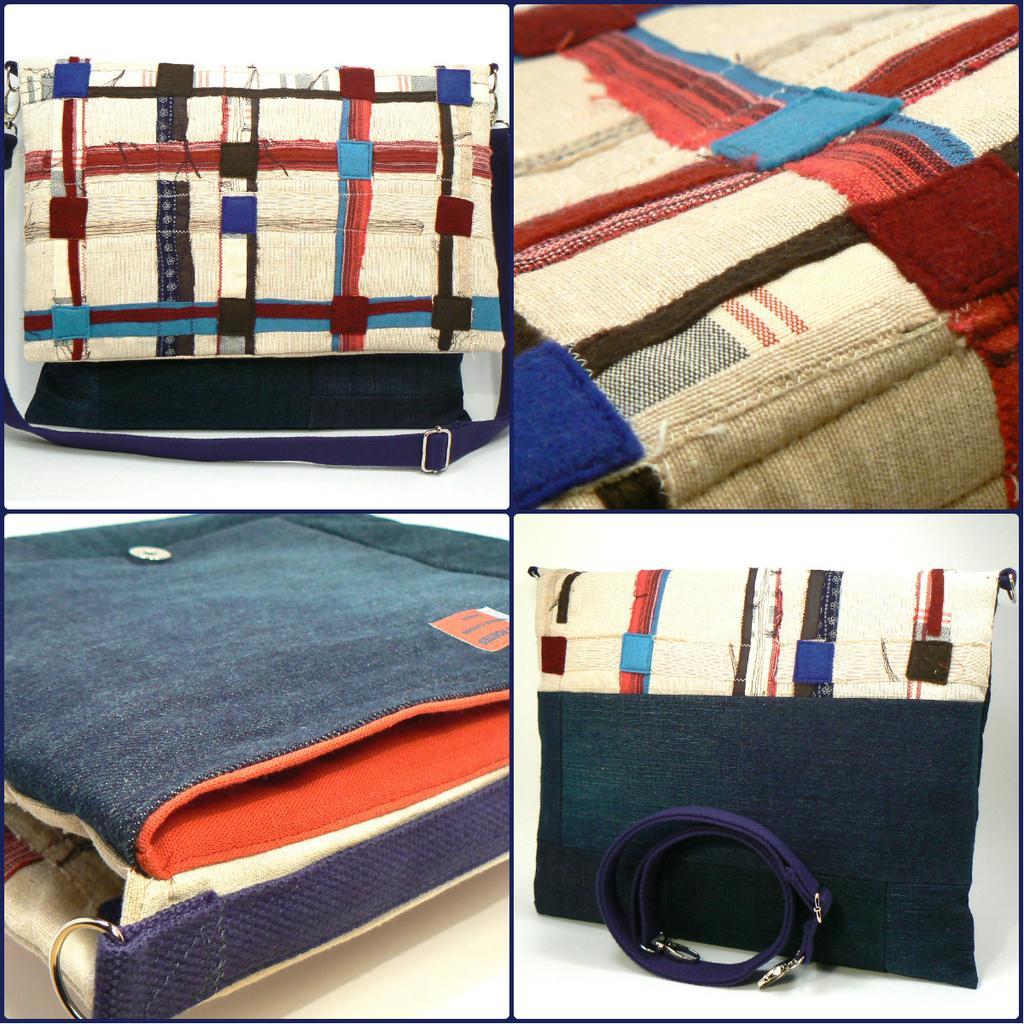How would you summarize this image in a sentence or two? This is the photo collage of a single bag which is made up of different color threads and it has a holder like thing which is made up of cloth and a steel button and a steel holder where it helps the bag and holder to attach. 